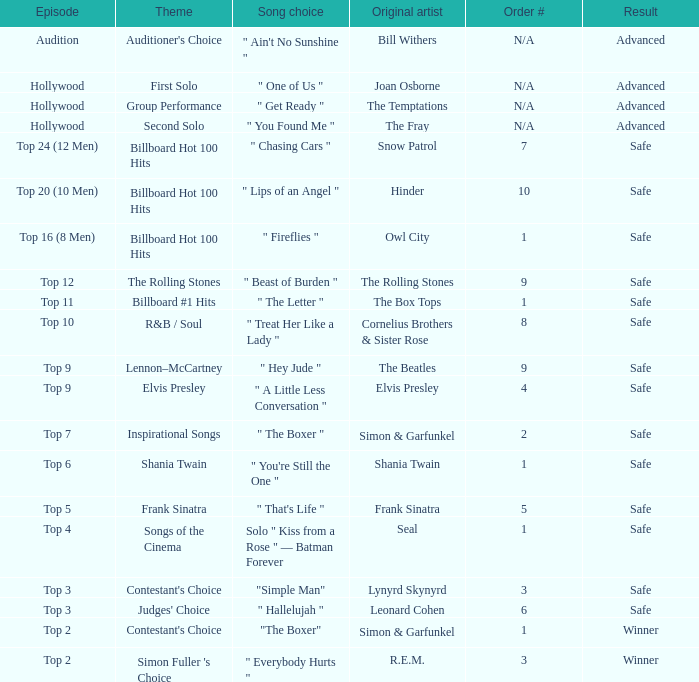The theme Auditioner's Choice	has what song choice? " Ain't No Sunshine ". 